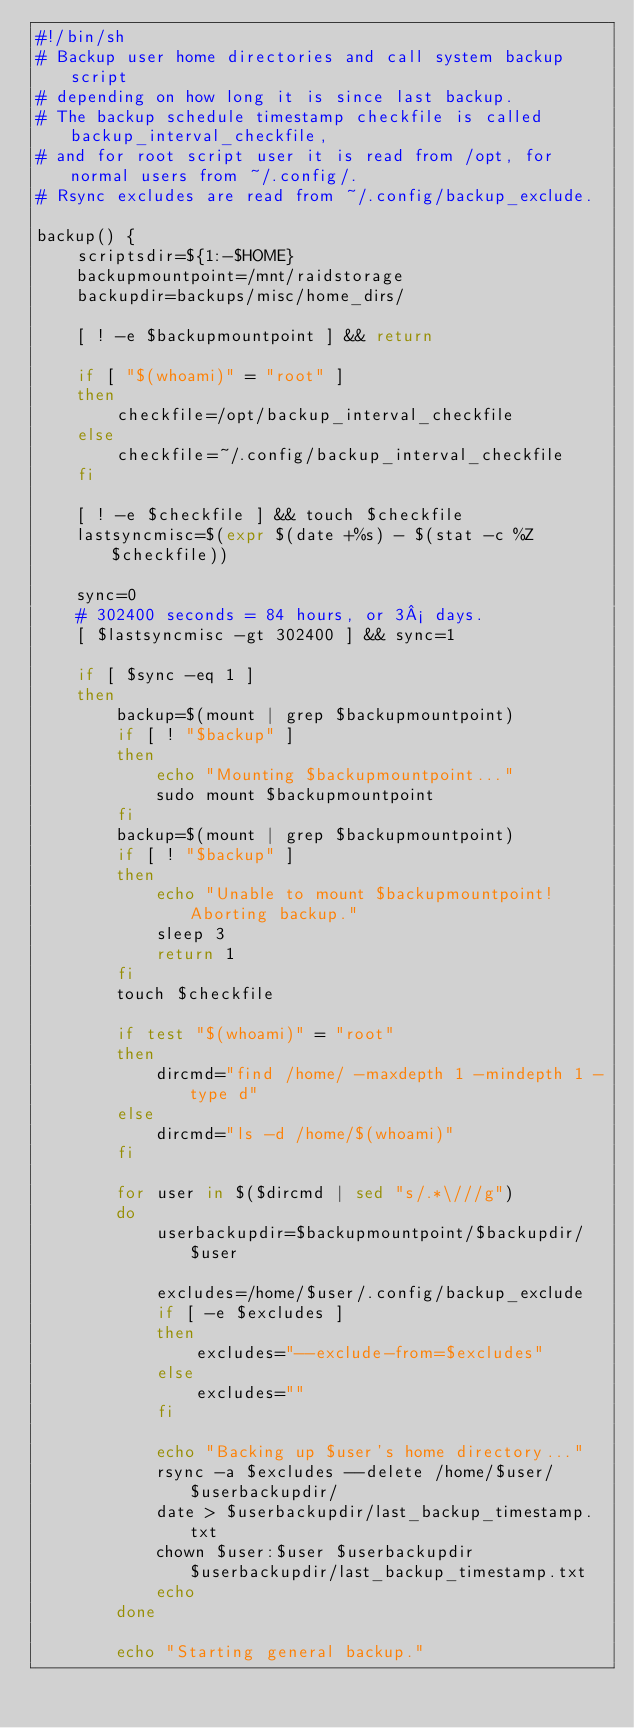<code> <loc_0><loc_0><loc_500><loc_500><_Bash_>#!/bin/sh
# Backup user home directories and call system backup script
# depending on how long it is since last backup.
# The backup schedule timestamp checkfile is called backup_interval_checkfile,
# and for root script user it is read from /opt, for normal users from ~/.config/.
# Rsync excludes are read from ~/.config/backup_exclude.

backup() {
    scriptsdir=${1:-$HOME}
    backupmountpoint=/mnt/raidstorage
    backupdir=backups/misc/home_dirs/

    [ ! -e $backupmountpoint ] && return

    if [ "$(whoami)" = "root" ]
    then
        checkfile=/opt/backup_interval_checkfile
    else
        checkfile=~/.config/backup_interval_checkfile
    fi

    [ ! -e $checkfile ] && touch $checkfile
    lastsyncmisc=$(expr $(date +%s) - $(stat -c %Z $checkfile))

    sync=0
    # 302400 seconds = 84 hours, or 3½ days.
    [ $lastsyncmisc -gt 302400 ] && sync=1

    if [ $sync -eq 1 ]
    then
        backup=$(mount | grep $backupmountpoint)
        if [ ! "$backup" ]
        then
            echo "Mounting $backupmountpoint..."
            sudo mount $backupmountpoint
        fi
        backup=$(mount | grep $backupmountpoint)
        if [ ! "$backup" ]
        then
            echo "Unable to mount $backupmountpoint! Aborting backup."
            sleep 3
            return 1
        fi
        touch $checkfile

        if test "$(whoami)" = "root"
        then
            dircmd="find /home/ -maxdepth 1 -mindepth 1 -type d"
        else
            dircmd="ls -d /home/$(whoami)"
        fi

        for user in $($dircmd | sed "s/.*\///g")
        do
            userbackupdir=$backupmountpoint/$backupdir/$user

            excludes=/home/$user/.config/backup_exclude
            if [ -e $excludes ]
            then
                excludes="--exclude-from=$excludes"
            else
                excludes=""
            fi

            echo "Backing up $user's home directory..."
            rsync -a $excludes --delete /home/$user/ $userbackupdir/
            date > $userbackupdir/last_backup_timestamp.txt
            chown $user:$user $userbackupdir $userbackupdir/last_backup_timestamp.txt
            echo
        done

        echo "Starting general backup."</code> 